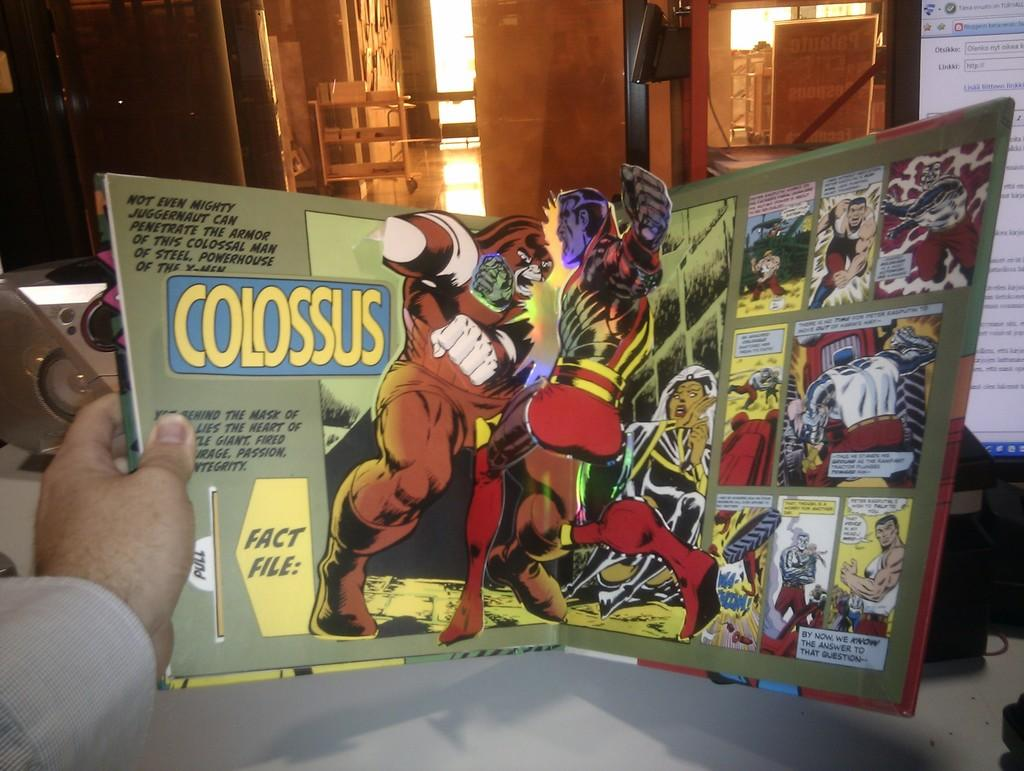<image>
Provide a brief description of the given image. A cloussus comic book is open to a page that shows to villans fighting each other 